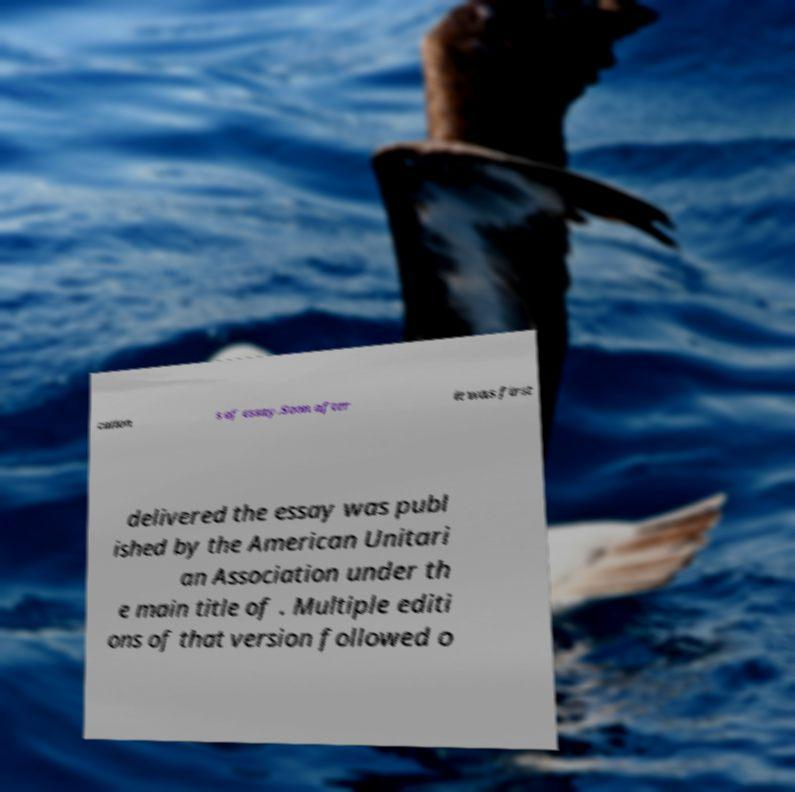Please read and relay the text visible in this image. What does it say? cation s of essay.Soon after it was first delivered the essay was publ ished by the American Unitari an Association under th e main title of . Multiple editi ons of that version followed o 